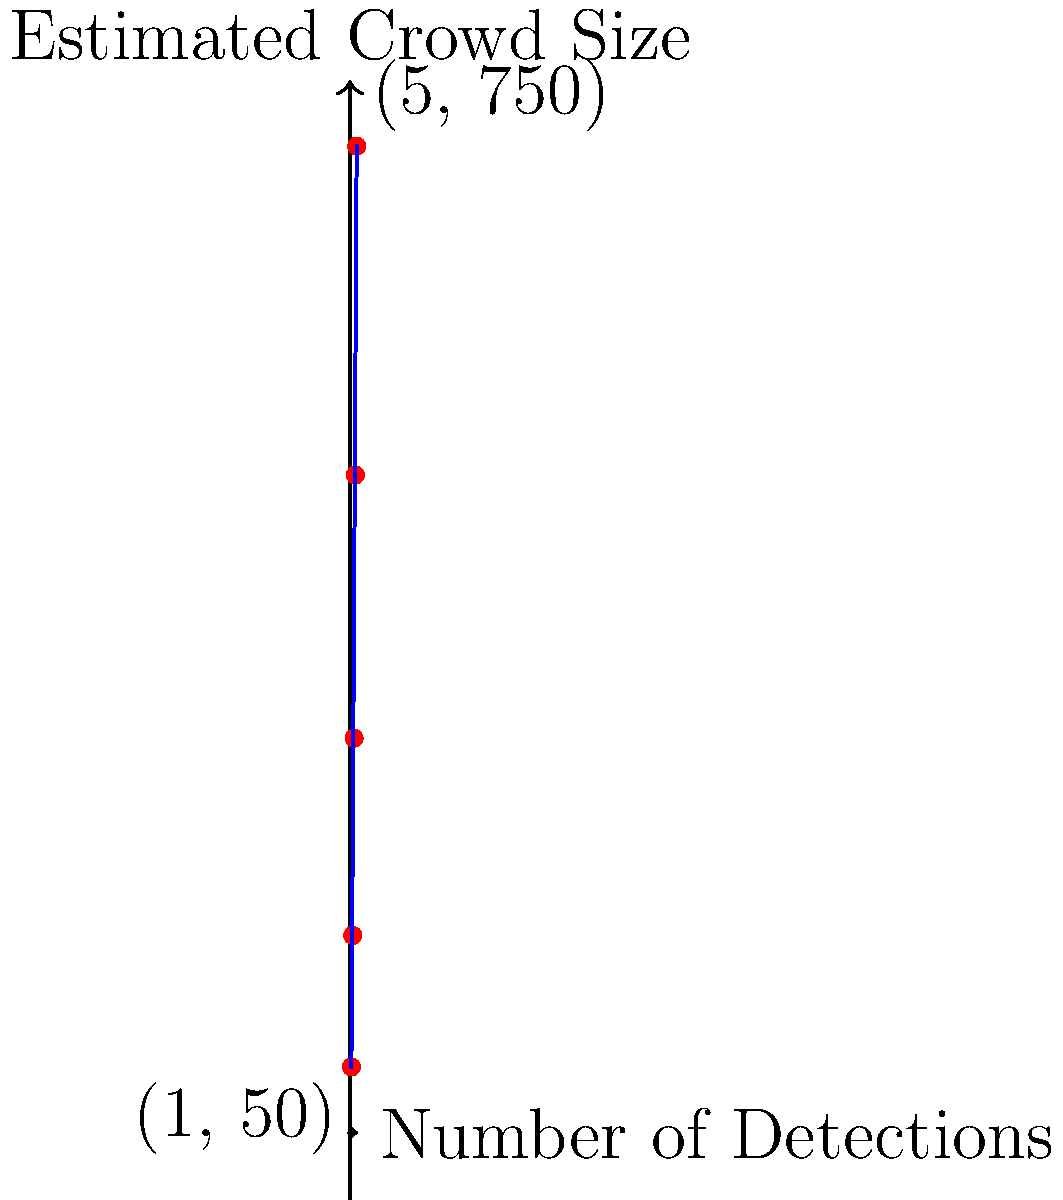As a novice Chinese screenwriter inspired by Mei Feng, you're working on a script for a historical drama with large crowd scenes. To help with production planning, you need to estimate the number of extras needed. Given the graph showing the relationship between object detections and estimated crowd size, what would be the approximate crowd size for a scene with 3 object detections? To solve this problem, we need to follow these steps:

1. Understand the graph:
   - The x-axis represents the number of object detections
   - The y-axis represents the estimated crowd size
   - There's a linear relationship between detections and crowd size

2. Identify the relevant points:
   - We see points at (1, 50) and (5, 750)

3. Calculate the slope of the line:
   $m = \frac{y_2 - y_1}{x_2 - x_1} = \frac{750 - 50}{5 - 1} = \frac{700}{4} = 175$

4. Use the point-slope form of a line:
   $y - y_1 = m(x - x_1)$
   Let's use (1, 50) as our reference point:
   $y - 50 = 175(x - 1)$

5. Solve for y when x = 3:
   $y - 50 = 175(3 - 1)$
   $y - 50 = 175 * 2 = 350$
   $y = 350 + 50 = 400$

Therefore, for 3 object detections, the estimated crowd size would be approximately 300 people.
Answer: 300 people 